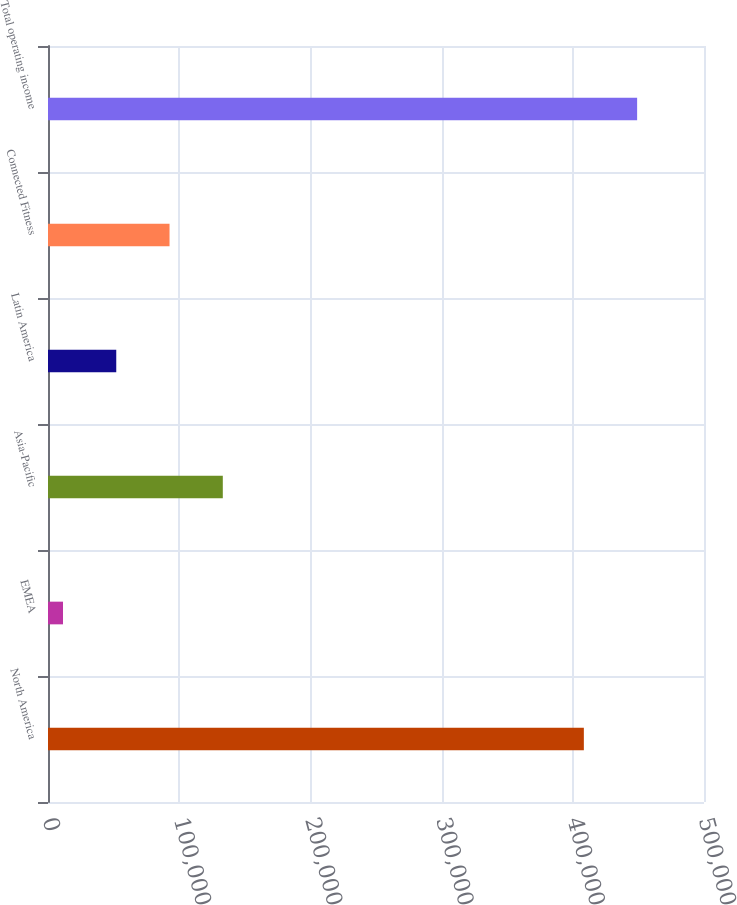<chart> <loc_0><loc_0><loc_500><loc_500><bar_chart><fcel>North America<fcel>EMEA<fcel>Asia-Pacific<fcel>Latin America<fcel>Connected Fitness<fcel>Total operating income<nl><fcel>408424<fcel>11420<fcel>133235<fcel>52025.1<fcel>92630.2<fcel>449029<nl></chart> 